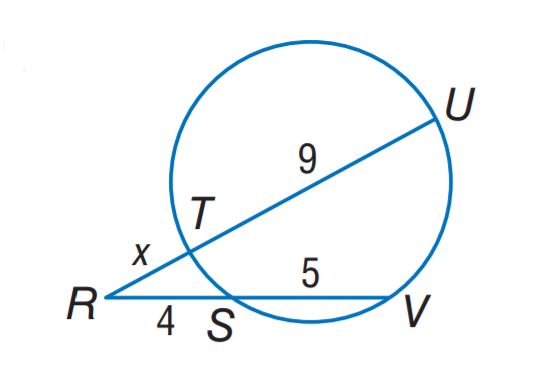Question: Find x.
Choices:
A. 2
B. 3
C. 4
D. 5
Answer with the letter. Answer: B 